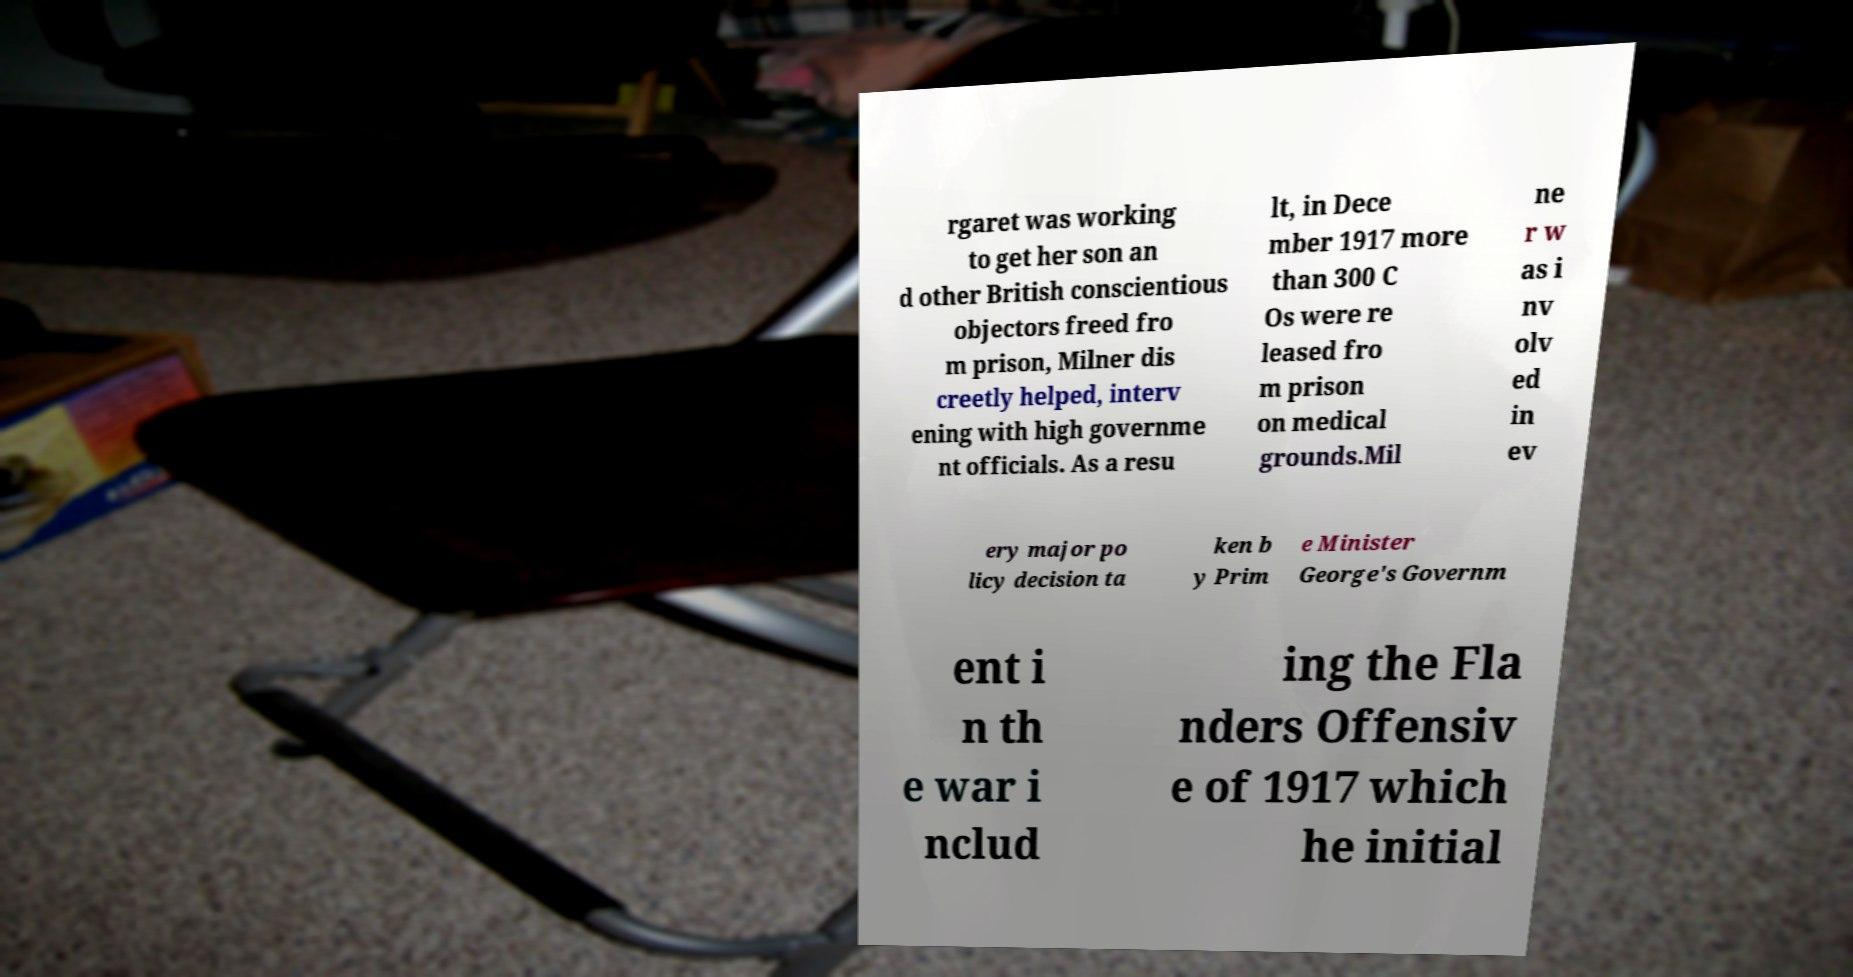Can you accurately transcribe the text from the provided image for me? rgaret was working to get her son an d other British conscientious objectors freed fro m prison, Milner dis creetly helped, interv ening with high governme nt officials. As a resu lt, in Dece mber 1917 more than 300 C Os were re leased fro m prison on medical grounds.Mil ne r w as i nv olv ed in ev ery major po licy decision ta ken b y Prim e Minister George's Governm ent i n th e war i nclud ing the Fla nders Offensiv e of 1917 which he initial 